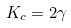<formula> <loc_0><loc_0><loc_500><loc_500>K _ { c } = 2 \gamma</formula> 